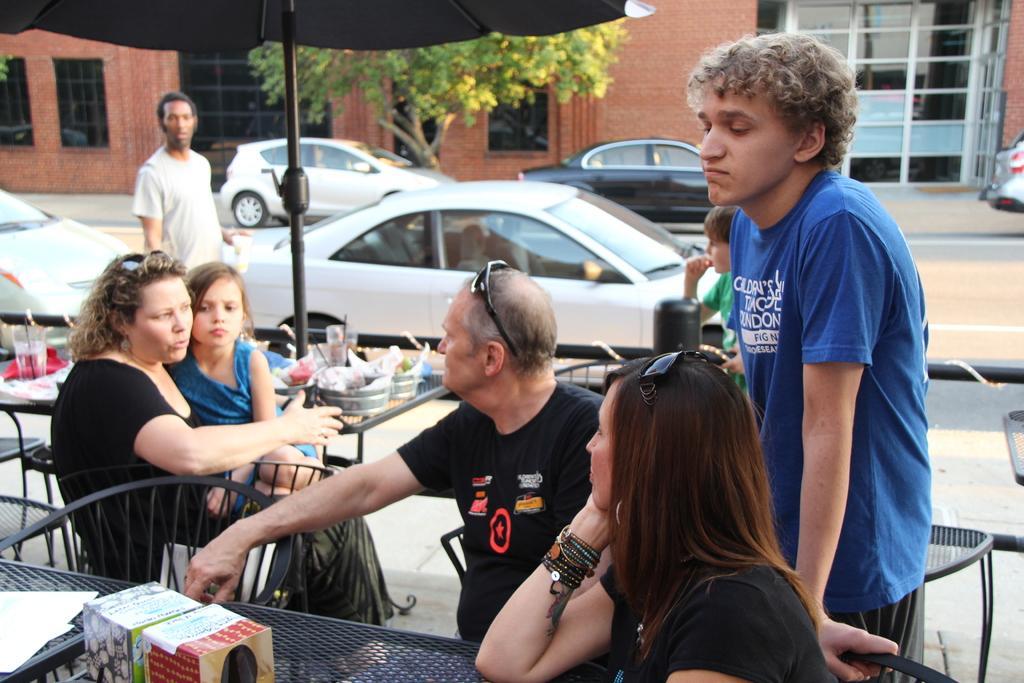In one or two sentences, can you explain what this image depicts? In this image, we can see people sitting on the chairs and some are standing and we can see boxes and some other objects on the tables. In the background, there are vehicles on the road and we can see a tree and buildings and there is an umbrella. 